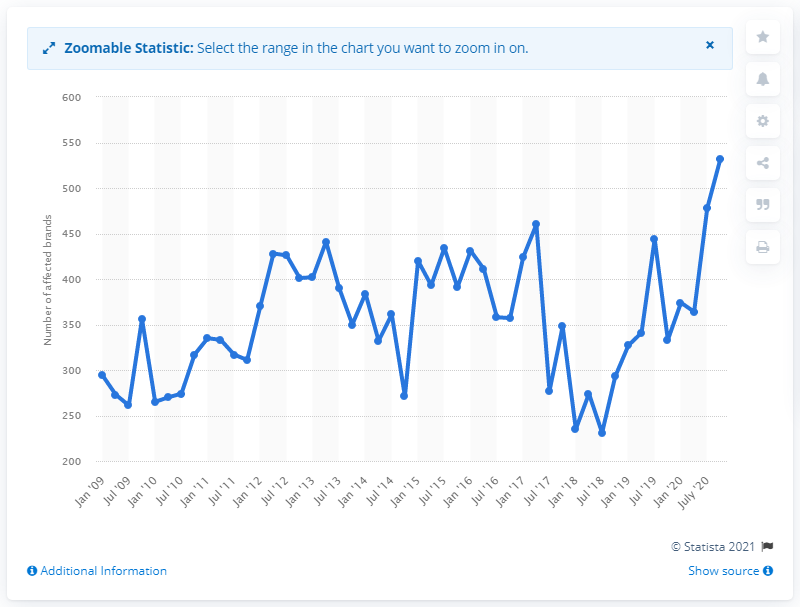Identify some key points in this picture. In October 2020, 532 brands were targeted by attacks. 